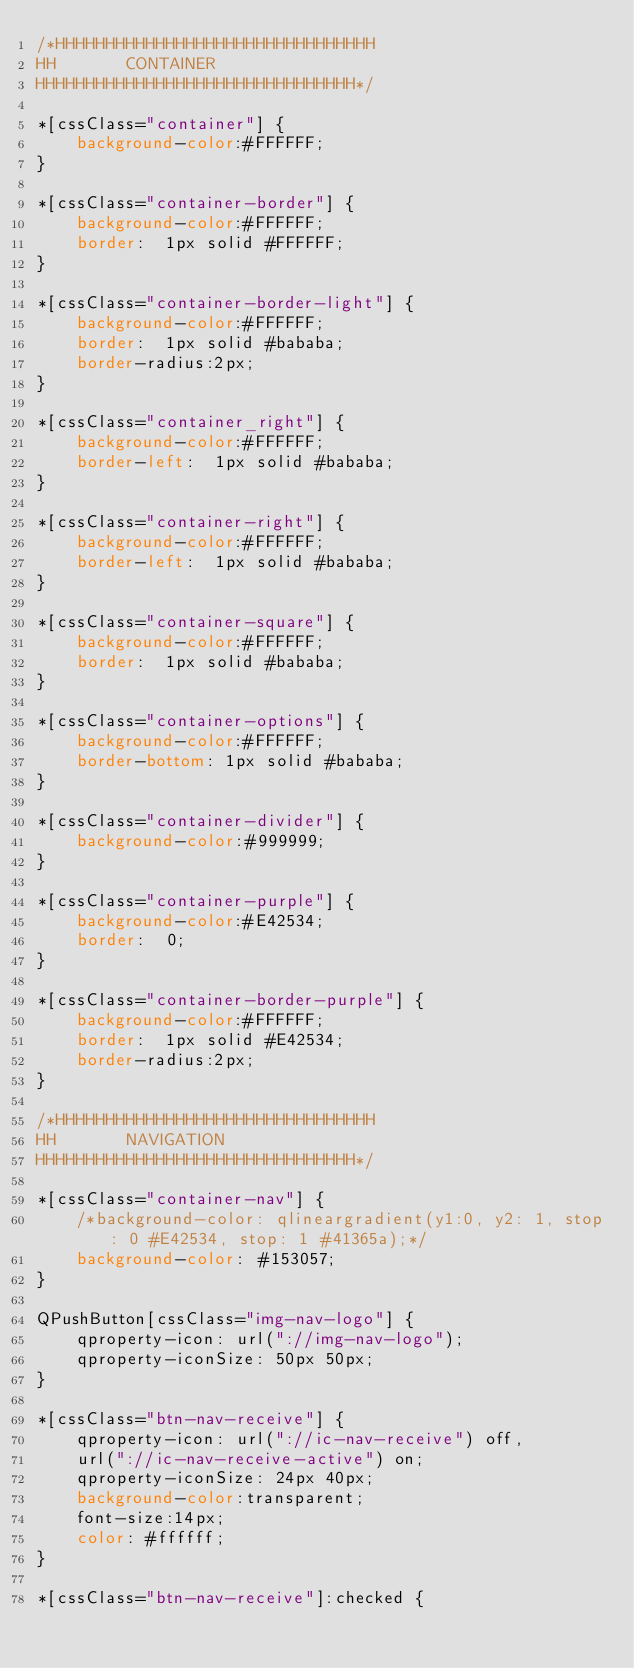Convert code to text. <code><loc_0><loc_0><loc_500><loc_500><_CSS_>/*HHHHHHHHHHHHHHHHHHHHHHHHHHHHHHHH
HH       CONTAINER
HHHHHHHHHHHHHHHHHHHHHHHHHHHHHHHH*/

*[cssClass="container"] {
    background-color:#FFFFFF;
}

*[cssClass="container-border"] {
    background-color:#FFFFFF;
    border:  1px solid #FFFFFF;
}

*[cssClass="container-border-light"] {
    background-color:#FFFFFF;
    border:  1px solid #bababa;
    border-radius:2px;
}

*[cssClass="container_right"] {
    background-color:#FFFFFF;
    border-left:  1px solid #bababa;
}

*[cssClass="container-right"] {
    background-color:#FFFFFF;
    border-left:  1px solid #bababa;
}

*[cssClass="container-square"] {
    background-color:#FFFFFF;
    border:  1px solid #bababa;
}

*[cssClass="container-options"] {
    background-color:#FFFFFF;
    border-bottom: 1px solid #bababa;
}

*[cssClass="container-divider"] {
    background-color:#999999;
}

*[cssClass="container-purple"] {
    background-color:#E42534;
    border:  0;
}

*[cssClass="container-border-purple"] {
    background-color:#FFFFFF;
    border:  1px solid #E42534;
    border-radius:2px;
}

/*HHHHHHHHHHHHHHHHHHHHHHHHHHHHHHHH
HH       NAVIGATION
HHHHHHHHHHHHHHHHHHHHHHHHHHHHHHHH*/

*[cssClass="container-nav"] {
    /*background-color: qlineargradient(y1:0, y2: 1, stop: 0 #E42534, stop: 1 #41365a);*/
    background-color: #153057;
}

QPushButton[cssClass="img-nav-logo"] {
    qproperty-icon: url("://img-nav-logo");
    qproperty-iconSize: 50px 50px;
}

*[cssClass="btn-nav-receive"] {
    qproperty-icon: url("://ic-nav-receive") off,
    url("://ic-nav-receive-active") on;
    qproperty-iconSize: 24px 40px;
    background-color:transparent;
    font-size:14px;
    color: #ffffff;
}

*[cssClass="btn-nav-receive"]:checked {</code> 